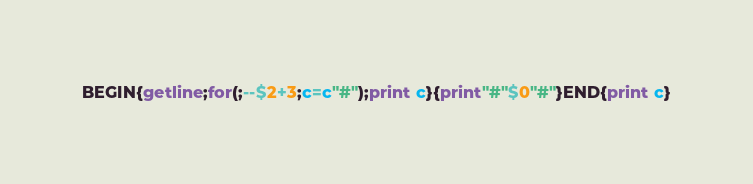Convert code to text. <code><loc_0><loc_0><loc_500><loc_500><_Awk_>BEGIN{getline;for(;--$2+3;c=c"#");print c}{print"#"$0"#"}END{print c}</code> 